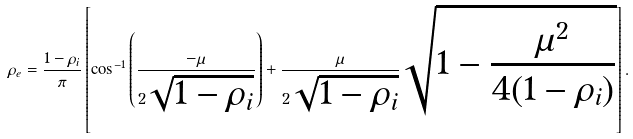Convert formula to latex. <formula><loc_0><loc_0><loc_500><loc_500>\rho _ { e } = \frac { 1 - \rho _ { i } } { \pi } \left [ \cos ^ { - 1 } \left ( \frac { - \mu } { 2 \sqrt { 1 - \rho _ { i } } } \right ) + \frac { \mu } { 2 \sqrt { 1 - \rho _ { i } } } \sqrt { 1 - \frac { \mu ^ { 2 } } { 4 ( 1 - \rho _ { i } ) } } \right ] .</formula> 